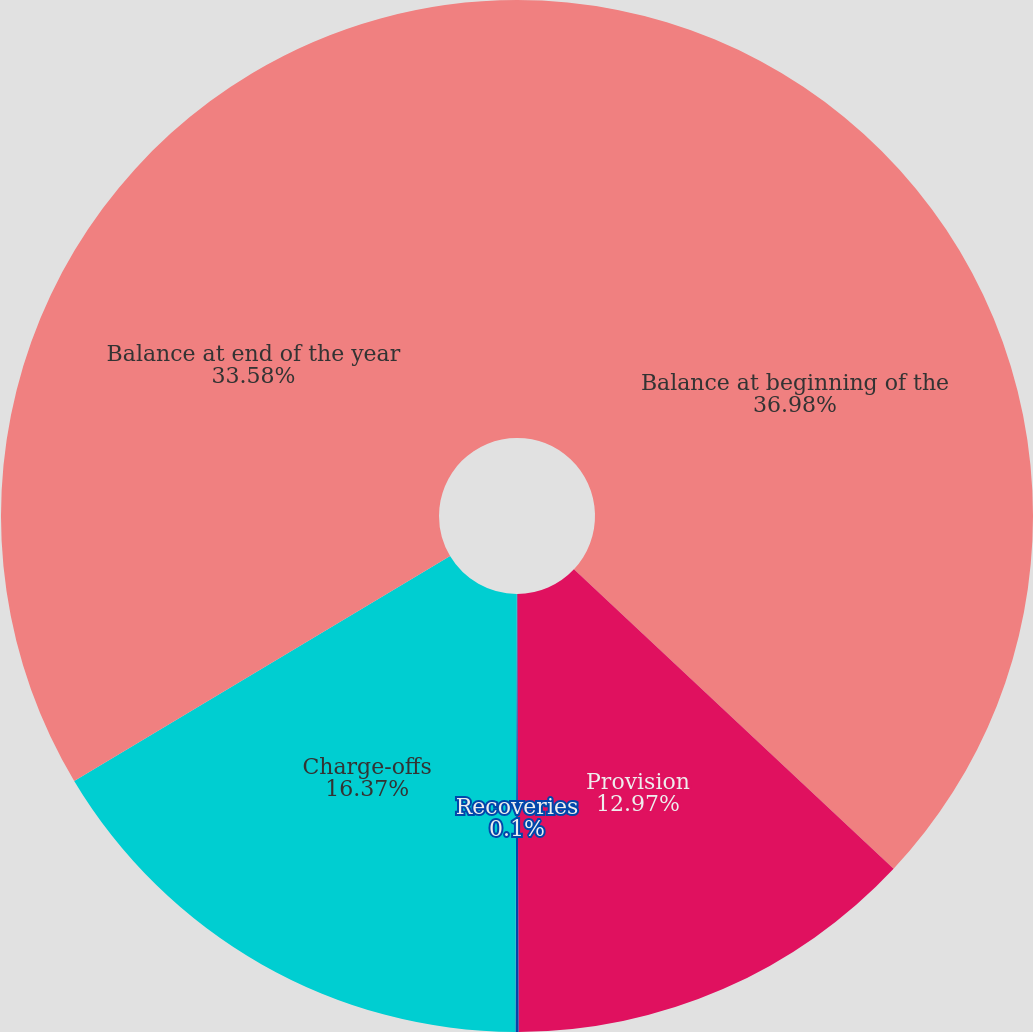Convert chart to OTSL. <chart><loc_0><loc_0><loc_500><loc_500><pie_chart><fcel>Balance at beginning of the<fcel>Provision<fcel>Recoveries<fcel>Charge-offs<fcel>Balance at end of the year<nl><fcel>36.98%<fcel>12.97%<fcel>0.1%<fcel>16.37%<fcel>33.58%<nl></chart> 